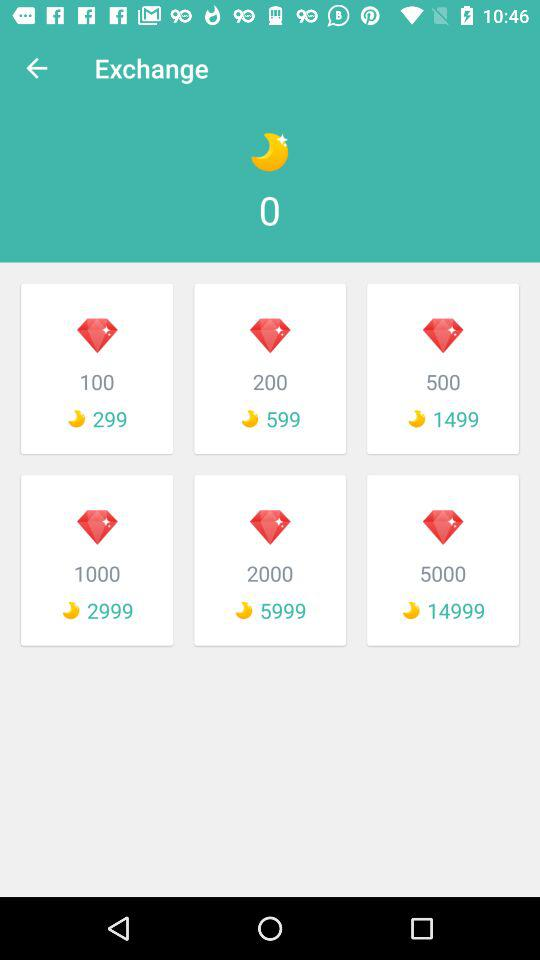What is the total number of moons available for exchange? The total number of moons available for exchange is 0. 